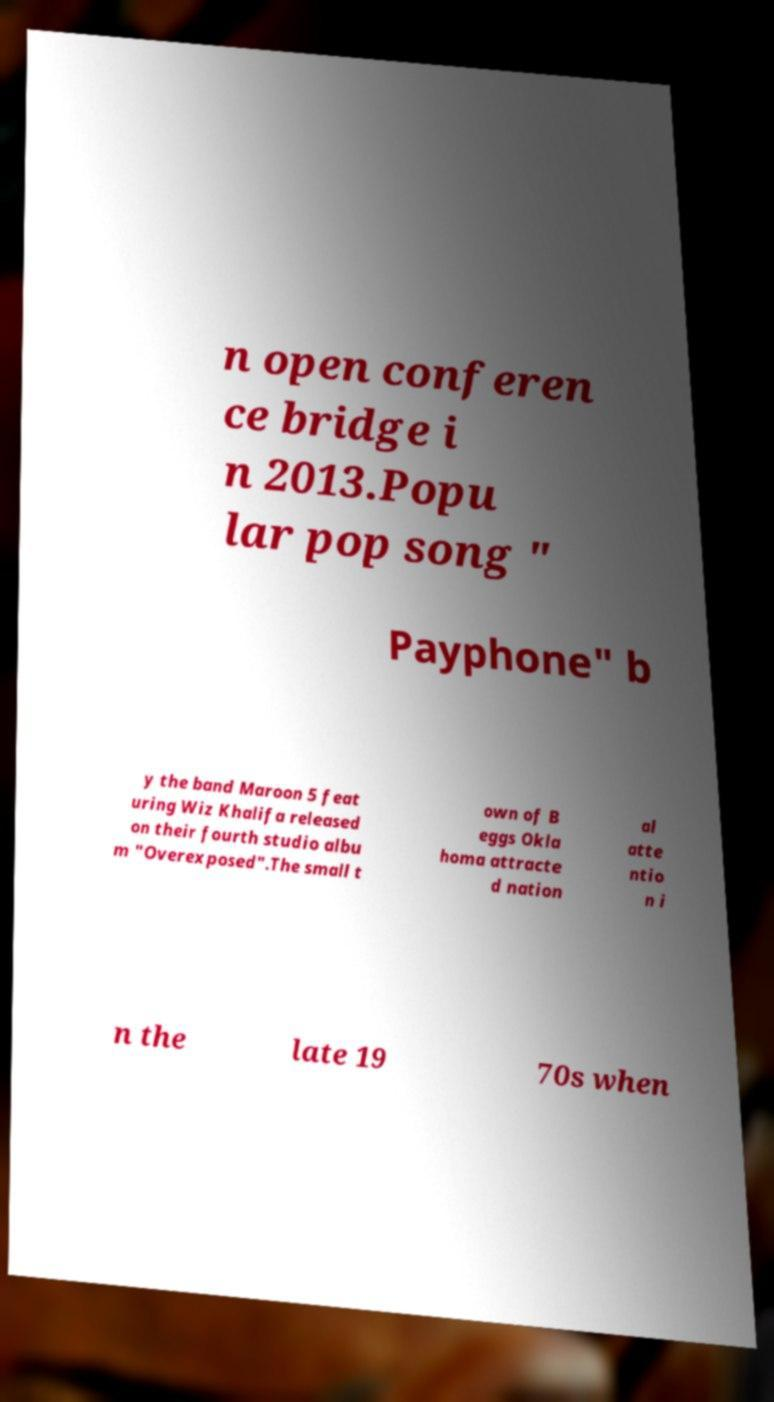Could you extract and type out the text from this image? n open conferen ce bridge i n 2013.Popu lar pop song " Payphone" b y the band Maroon 5 feat uring Wiz Khalifa released on their fourth studio albu m "Overexposed".The small t own of B eggs Okla homa attracte d nation al atte ntio n i n the late 19 70s when 